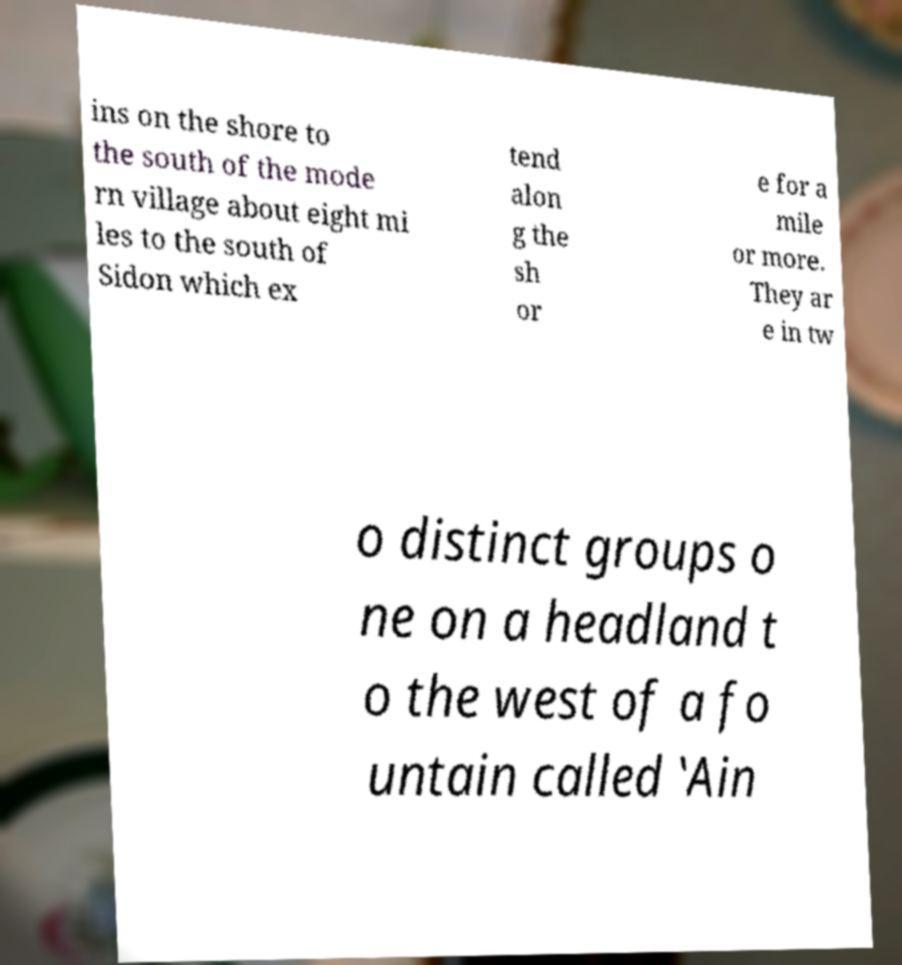Could you assist in decoding the text presented in this image and type it out clearly? ins on the shore to the south of the mode rn village about eight mi les to the south of Sidon which ex tend alon g the sh or e for a mile or more. They ar e in tw o distinct groups o ne on a headland t o the west of a fo untain called ‛Ain 